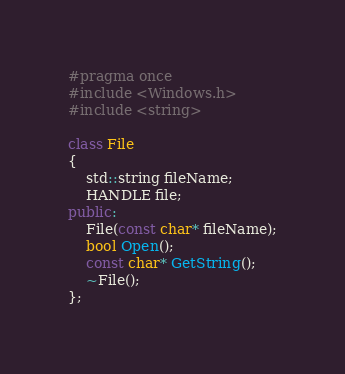Convert code to text. <code><loc_0><loc_0><loc_500><loc_500><_C++_>#pragma once
#include <Windows.h>
#include <string>

class File
{
	std::string fileName;
	HANDLE file;
public:
	File(const char* fileName);
	bool Open();
	const char* GetString();
	~File();
};

</code> 